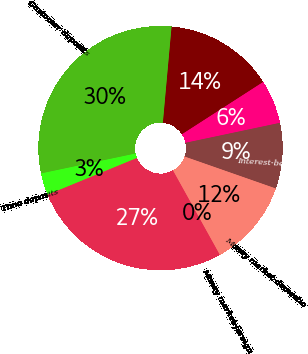Convert chart. <chart><loc_0><loc_0><loc_500><loc_500><pie_chart><fcel>Non-interest-bearing demand<fcel>Savings<fcel>Interest-bearing transaction<fcel>Money market-domestic<fcel>Money market-foreign<fcel>Low-cost deposits<fcel>Time deposits<fcel>Customer deposits<nl><fcel>14.46%<fcel>5.79%<fcel>8.68%<fcel>11.57%<fcel>0.01%<fcel>26.86%<fcel>2.9%<fcel>29.75%<nl></chart> 